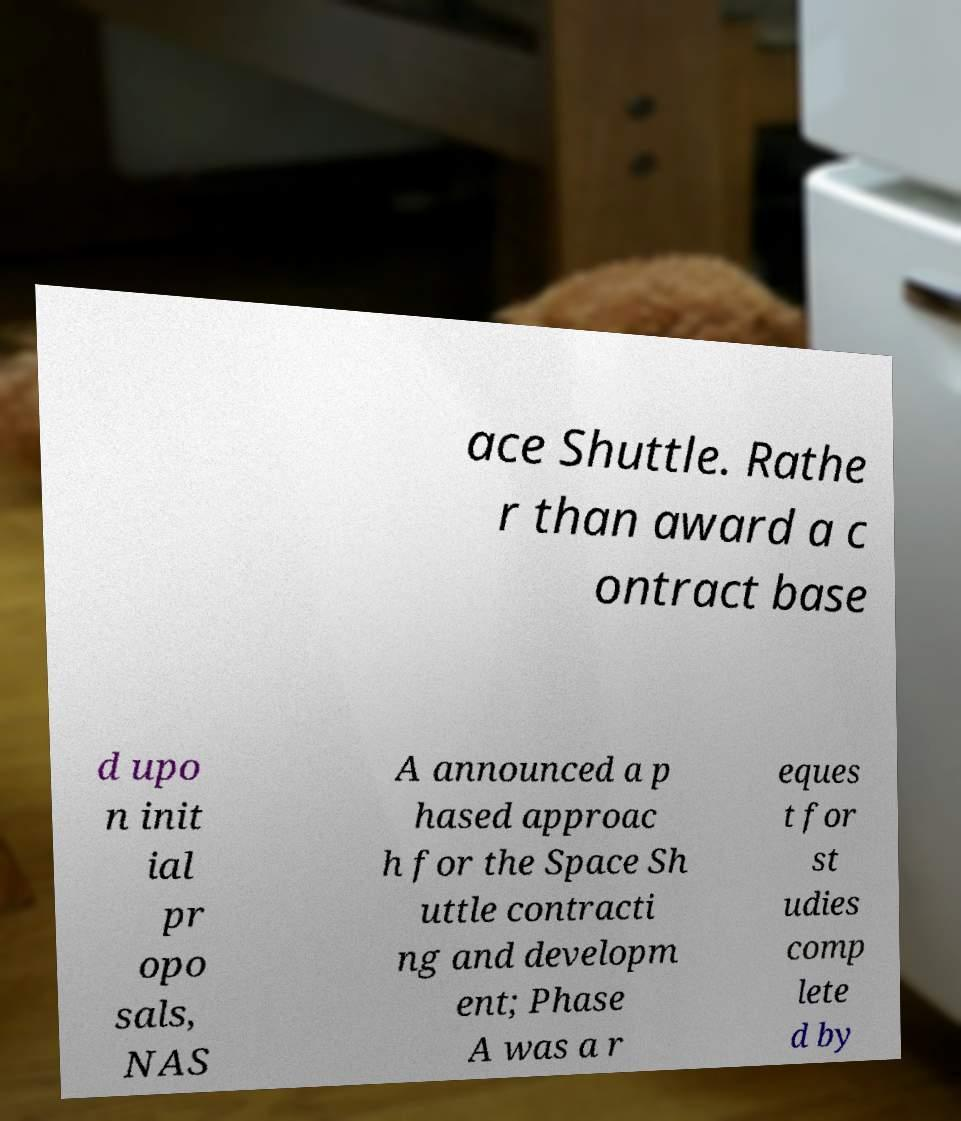What messages or text are displayed in this image? I need them in a readable, typed format. ace Shuttle. Rathe r than award a c ontract base d upo n init ial pr opo sals, NAS A announced a p hased approac h for the Space Sh uttle contracti ng and developm ent; Phase A was a r eques t for st udies comp lete d by 